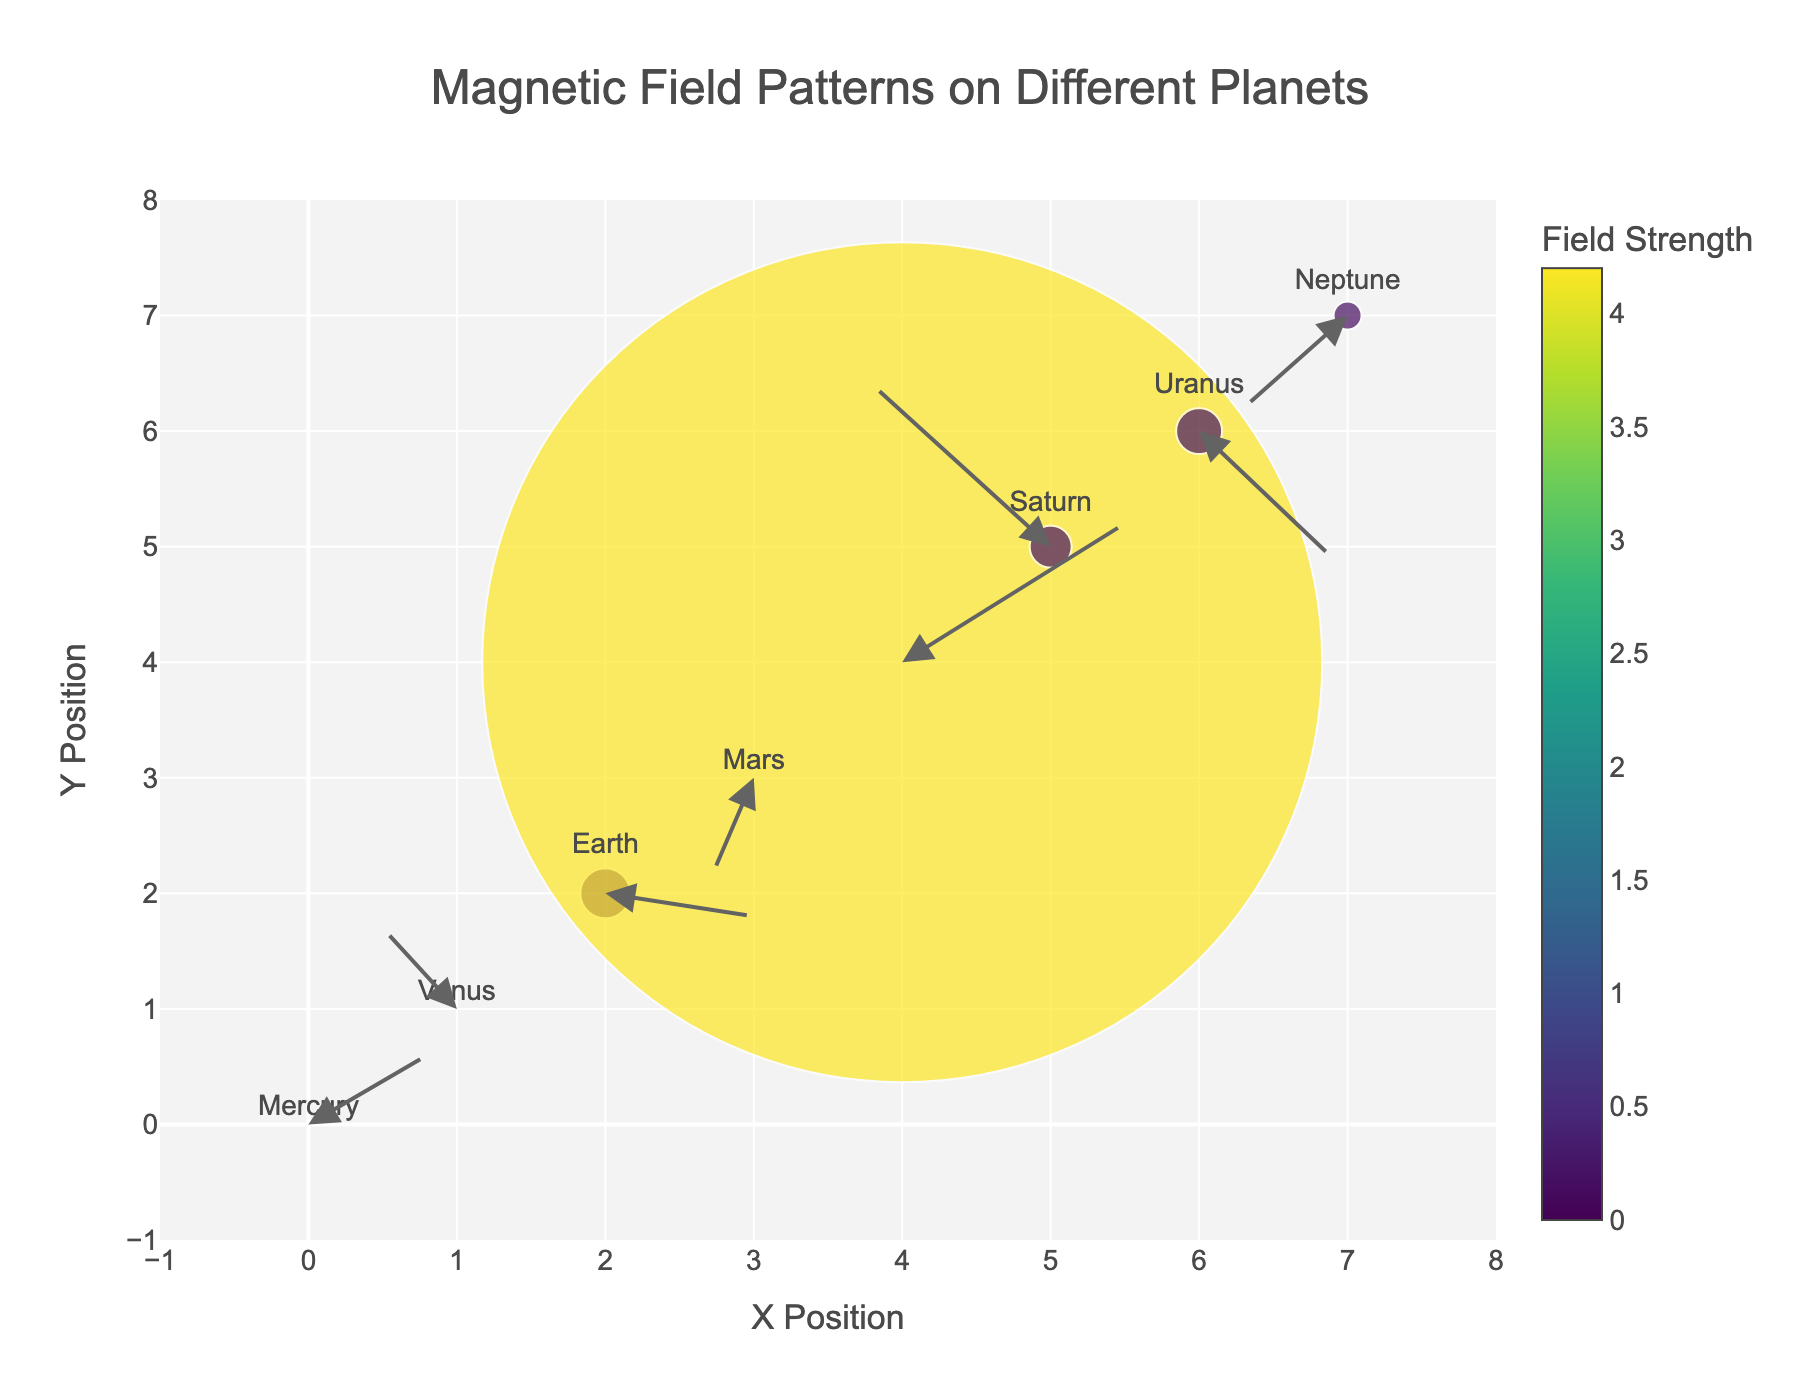How many planets are displayed in the plot? Count the number of different planets labeled in the plot as markers.
Answer: 8 Which planet has the highest magnetic field strength? Look for the planet with the largest marker size and the highest color intensity on the color scale.
Answer: Jupiter Compare the magnetic field directions of Earth and Mars. Which one points downward? Observe the annotations (arrows) attached to each planet's marker. Earth's arrow points in a downward direction.
Answer: Earth Based on the visual data, which planet has almost no magnetic field? Identify the planet with the smallest marker size and the lightest color on the color scale.
Answer: Venus Is there any planet whose marker is closer to the origin (0, 0) than Mercury's marker? Compare the distance of each planet's marker from the origin. Mercury's marker is at the origin (0, 0), so no other planet is closer.
Answer: No Which planet has a magnetic field vector that points mostly horizontally? Look for a planet with a magnetic field annotation (arrow) that is predominantly horizontal. Jupiter's arrow has a significant horizontal component compared to others.
Answer: Jupiter What is the relationship between field strength and marker size? Observe that larger marker sizes correspond to higher field strengths, as indicated by the size scaling on the color bar.
Answer: Positive correlation Arrange the planets in order of increasing magnetic field strength. Rank the planets by their marker size and color intensity: Venus < Mars < Mercury < Neptune < Saturn < Uranus < Earth < Jupiter.
Answer: Venus, Mars, Mercury, Neptune, Saturn, Uranus, Earth, Jupiter Do any planets have magnetic field vectors pointing to the left? Observe the direction of the arrows attached to each planet's marker. Venus and Saturn have arrows pointing left.
Answer: Yes Which planet's magnetic field vector has the largest vertical component upwards? Examine the vertical components of the annotations (arrows). Saturn has the largest upward vertical component.
Answer: Saturn 